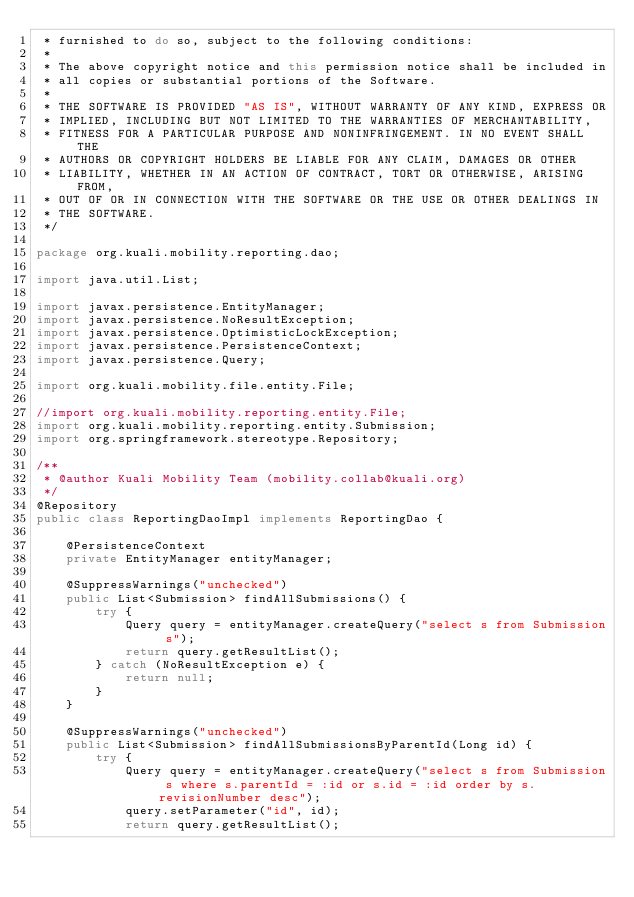<code> <loc_0><loc_0><loc_500><loc_500><_Java_> * furnished to do so, subject to the following conditions:
 *
 * The above copyright notice and this permission notice shall be included in
 * all copies or substantial portions of the Software.
 *
 * THE SOFTWARE IS PROVIDED "AS IS", WITHOUT WARRANTY OF ANY KIND, EXPRESS OR
 * IMPLIED, INCLUDING BUT NOT LIMITED TO THE WARRANTIES OF MERCHANTABILITY,
 * FITNESS FOR A PARTICULAR PURPOSE AND NONINFRINGEMENT. IN NO EVENT SHALL THE
 * AUTHORS OR COPYRIGHT HOLDERS BE LIABLE FOR ANY CLAIM, DAMAGES OR OTHER
 * LIABILITY, WHETHER IN AN ACTION OF CONTRACT, TORT OR OTHERWISE, ARISING FROM,
 * OUT OF OR IN CONNECTION WITH THE SOFTWARE OR THE USE OR OTHER DEALINGS IN
 * THE SOFTWARE.
 */

package org.kuali.mobility.reporting.dao;

import java.util.List;

import javax.persistence.EntityManager;
import javax.persistence.NoResultException;
import javax.persistence.OptimisticLockException;
import javax.persistence.PersistenceContext;
import javax.persistence.Query;

import org.kuali.mobility.file.entity.File;

//import org.kuali.mobility.reporting.entity.File;
import org.kuali.mobility.reporting.entity.Submission;
import org.springframework.stereotype.Repository;

/**
 * @author Kuali Mobility Team (mobility.collab@kuali.org)
 */
@Repository
public class ReportingDaoImpl implements ReportingDao {

	@PersistenceContext
	private EntityManager entityManager;

	@SuppressWarnings("unchecked")
	public List<Submission> findAllSubmissions() {
		try {
			Query query = entityManager.createQuery("select s from Submission s");
			return query.getResultList();
		} catch (NoResultException e) {
			return null;
		}
	}

	@SuppressWarnings("unchecked")
	public List<Submission> findAllSubmissionsByParentId(Long id) {
		try {
			Query query = entityManager.createQuery("select s from Submission s where s.parentId = :id or s.id = :id order by s.revisionNumber desc");
			query.setParameter("id", id);
			return query.getResultList();</code> 